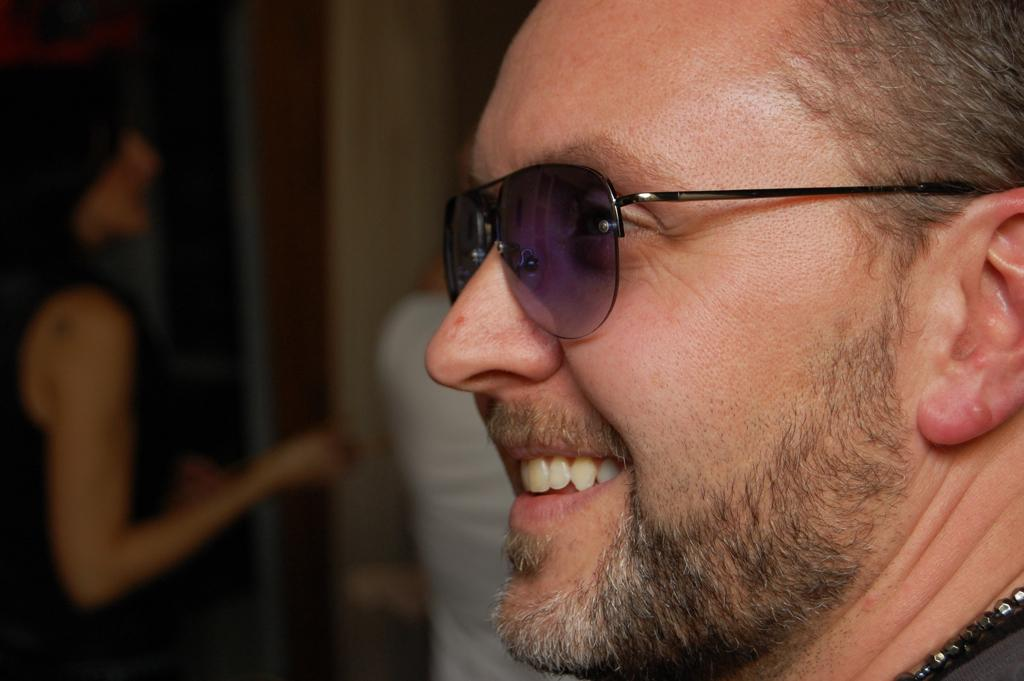What is the main subject in the foreground of the image? There is a man in the foreground of the image. What is the man's facial expression in the image? The man is smiling in the image. What accessory is the man wearing in the image? The man is wearing glasses in the image. What type of print can be seen on the man's shirt in the image? There is no information about the man's shirt in the provided facts, so we cannot determine if there is a print on it. 